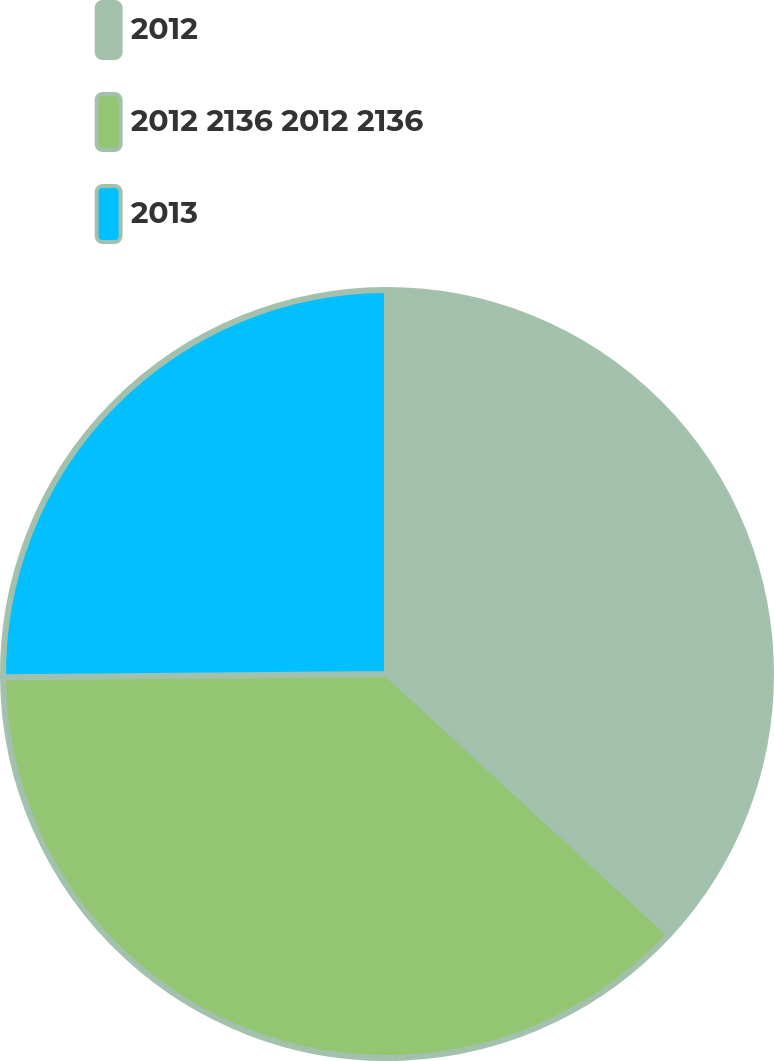Convert chart to OTSL. <chart><loc_0><loc_0><loc_500><loc_500><pie_chart><fcel>2012<fcel>2012 2136 2012 2136<fcel>2013<nl><fcel>36.85%<fcel>38.02%<fcel>25.13%<nl></chart> 